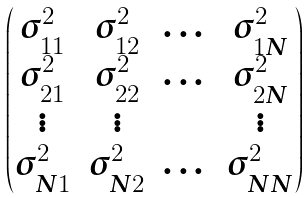Convert formula to latex. <formula><loc_0><loc_0><loc_500><loc_500>\begin{pmatrix} \sigma ^ { 2 } _ { 1 1 } & \sigma ^ { 2 } _ { 1 2 } & \dots & \sigma ^ { 2 } _ { 1 N } \\ \sigma ^ { 2 } _ { 2 1 } & \sigma ^ { 2 } _ { 2 2 } & \dots & \sigma ^ { 2 } _ { 2 N } \\ \vdots & \vdots & & \vdots \\ \sigma ^ { 2 } _ { N 1 } & \sigma ^ { 2 } _ { N 2 } & \dots & \sigma ^ { 2 } _ { N N } \\ \end{pmatrix}</formula> 